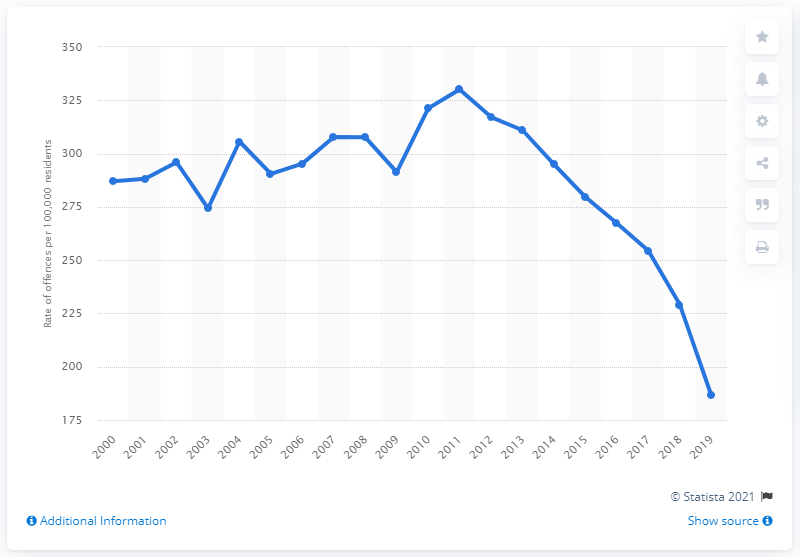Identify some key points in this picture. In 2019, there were approximately 186.6 drug-related offenses per 100,000 residents in Canada. 